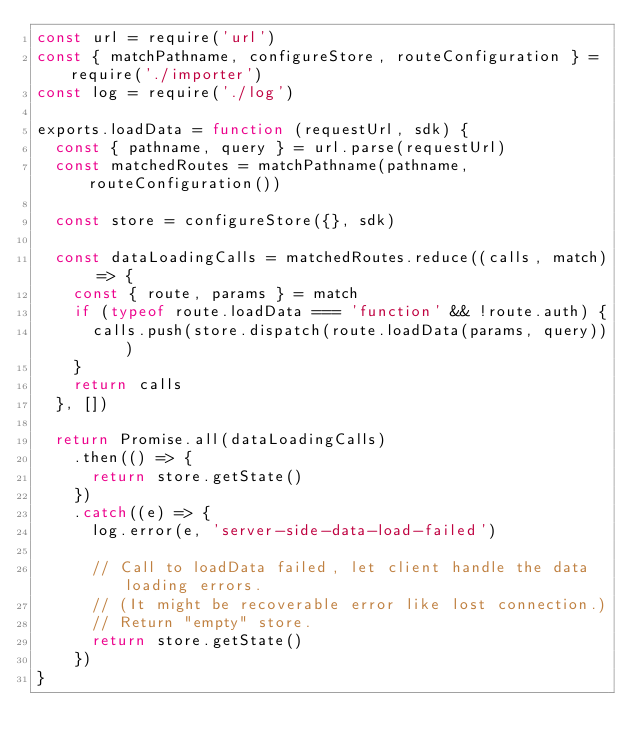<code> <loc_0><loc_0><loc_500><loc_500><_JavaScript_>const url = require('url')
const { matchPathname, configureStore, routeConfiguration } = require('./importer')
const log = require('./log')

exports.loadData = function (requestUrl, sdk) {
  const { pathname, query } = url.parse(requestUrl)
  const matchedRoutes = matchPathname(pathname, routeConfiguration())

  const store = configureStore({}, sdk)

  const dataLoadingCalls = matchedRoutes.reduce((calls, match) => {
    const { route, params } = match
    if (typeof route.loadData === 'function' && !route.auth) {
      calls.push(store.dispatch(route.loadData(params, query)))
    }
    return calls
  }, [])

  return Promise.all(dataLoadingCalls)
    .then(() => {
      return store.getState()
    })
    .catch((e) => {
      log.error(e, 'server-side-data-load-failed')

      // Call to loadData failed, let client handle the data loading errors.
      // (It might be recoverable error like lost connection.)
      // Return "empty" store.
      return store.getState()
    })
}
</code> 